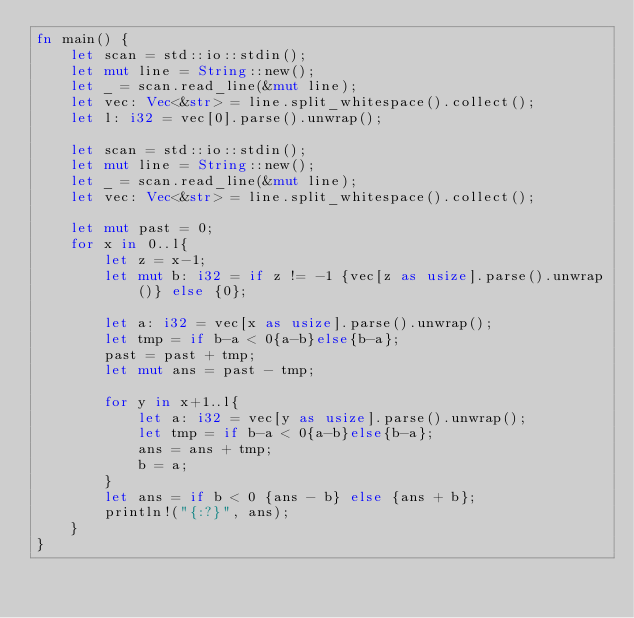<code> <loc_0><loc_0><loc_500><loc_500><_Rust_>fn main() {
    let scan = std::io::stdin();
    let mut line = String::new();
    let _ = scan.read_line(&mut line);
    let vec: Vec<&str> = line.split_whitespace().collect();
    let l: i32 = vec[0].parse().unwrap();

    let scan = std::io::stdin();
    let mut line = String::new();
    let _ = scan.read_line(&mut line);
    let vec: Vec<&str> = line.split_whitespace().collect();

    let mut past = 0;
    for x in 0..l{
        let z = x-1;
        let mut b: i32 = if z != -1 {vec[z as usize].parse().unwrap()} else {0};

        let a: i32 = vec[x as usize].parse().unwrap();
        let tmp = if b-a < 0{a-b}else{b-a};
        past = past + tmp;
        let mut ans = past - tmp;

        for y in x+1..l{
            let a: i32 = vec[y as usize].parse().unwrap();
            let tmp = if b-a < 0{a-b}else{b-a};
            ans = ans + tmp;
            b = a;
        }
        let ans = if b < 0 {ans - b} else {ans + b};
        println!("{:?}", ans);
    }
}
</code> 